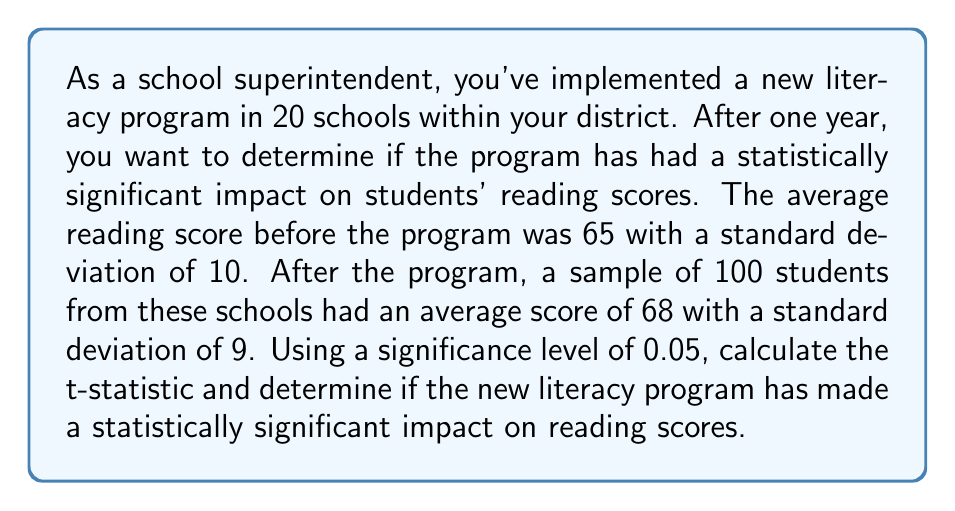Help me with this question. To determine if the new literacy program has made a statistically significant impact, we'll use a one-sample t-test. We'll follow these steps:

1) First, let's state our hypotheses:
   $H_0: \mu = 65$ (null hypothesis: the population mean is equal to the pre-program mean)
   $H_a: \mu > 65$ (alternative hypothesis: the population mean is greater than the pre-program mean)

2) We'll use the t-statistic formula:

   $t = \frac{\bar{x} - \mu_0}{s / \sqrt{n}}$

   Where:
   $\bar{x}$ = sample mean (68)
   $\mu_0$ = hypothesized population mean (65)
   $s$ = sample standard deviation (9)
   $n$ = sample size (100)

3) Let's plug in our values:

   $t = \frac{68 - 65}{9 / \sqrt{100}} = \frac{3}{9/10} = \frac{3}{0.9} = 3.33$

4) Now, we need to find the critical t-value. With a significance level of 0.05 and 99 degrees of freedom (n-1), the critical t-value is approximately 1.66 (from a t-table or calculator).

5) Compare the calculated t-statistic to the critical t-value:
   3.33 > 1.66

6) Since our calculated t-statistic (3.33) is greater than the critical t-value (1.66), we reject the null hypothesis.

7) We can also calculate the p-value, which would be less than 0.05, confirming our decision to reject the null hypothesis.
Answer: The calculated t-statistic is 3.33. Since 3.33 > 1.66 (the critical t-value), we reject the null hypothesis. Therefore, we conclude that the new literacy program has made a statistically significant positive impact on reading scores. 